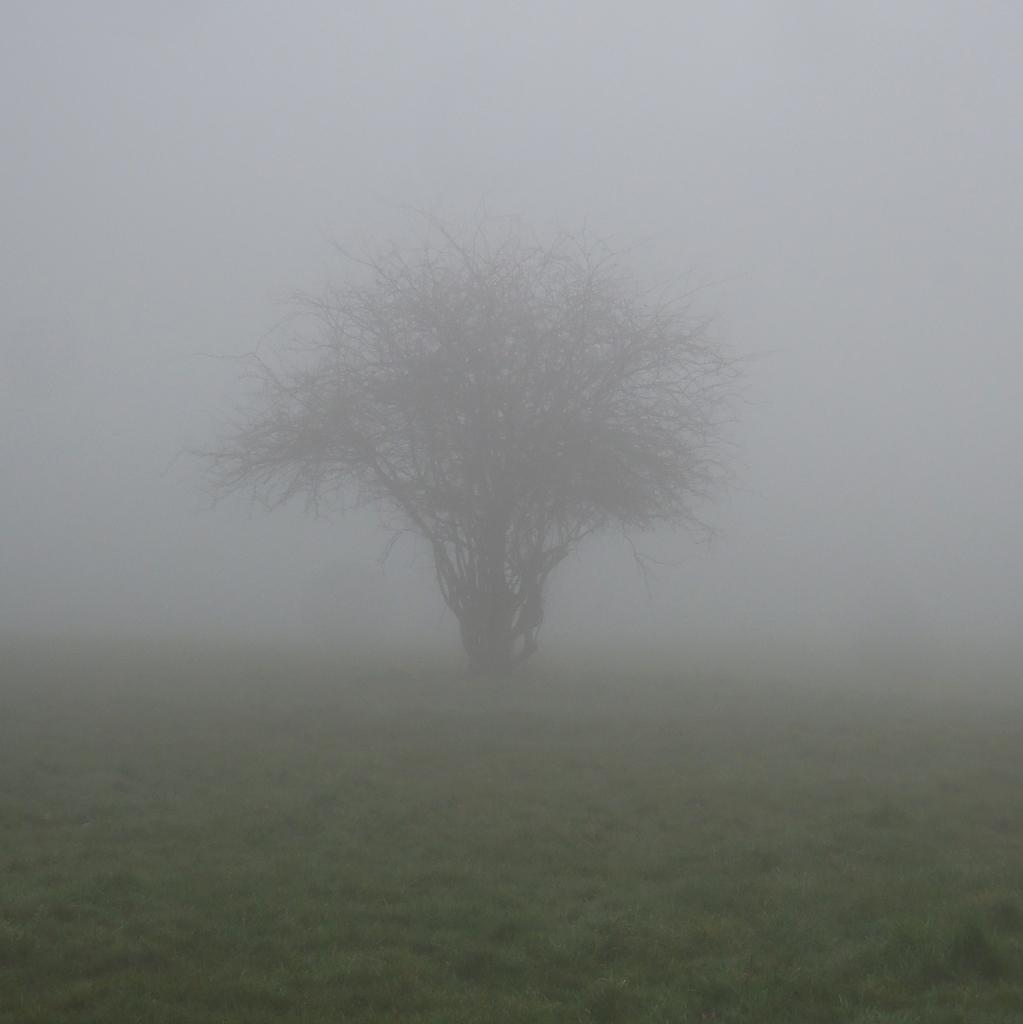What is the main subject in the center of the image? There is a tree in the center of the image. What type of vegetation is at the bottom of the image? There is grass at the bottom of the image. What can be seen in the background of the image? There is fog in the background of the image. How many tomatoes are hanging from the tree in the image? There are no tomatoes present in the image; it features a tree with no visible fruits or vegetables. Is there a sink visible in the image? There is no sink present in the image. 